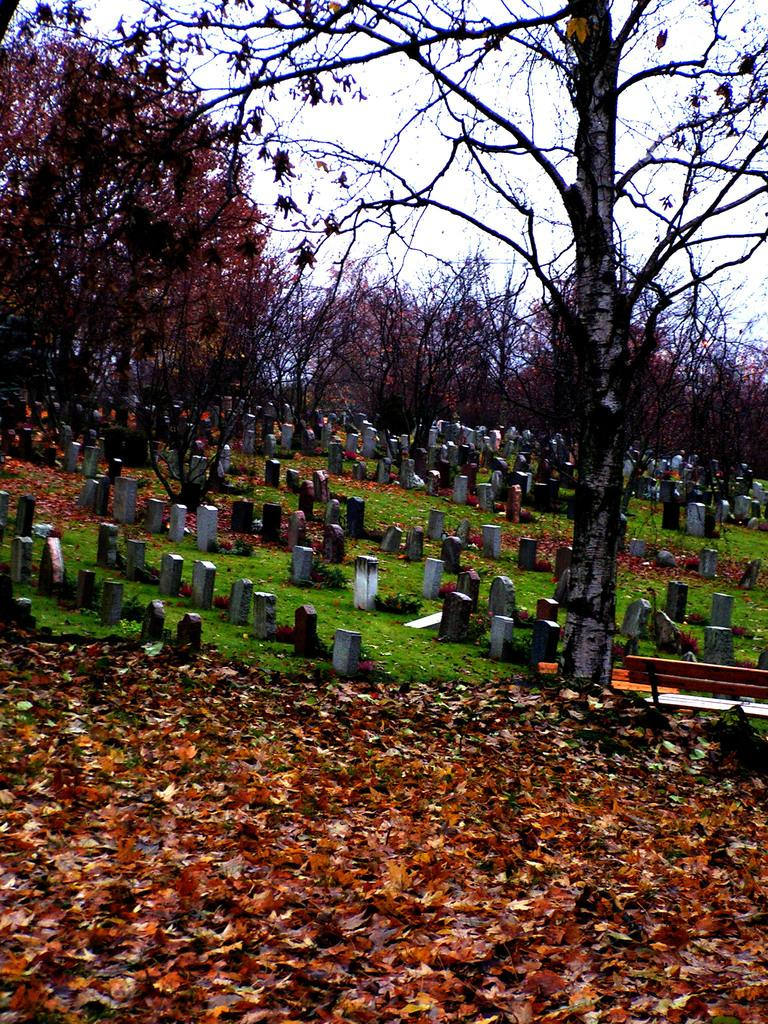What type of natural elements can be seen in the front of the image? There are dry leaves in the front of the image. What can be found in the center of the image? There are stones and a dry tree in the center of the image. What is visible in the background of the image? There are trees and grass on the ground in the background of the image. How many rings can be seen on the dry tree in the image? There are no rings visible on the dry tree in the image. Is there a coast visible in the background of the image? There is no coast present in the image; it features trees and grass in the background. 